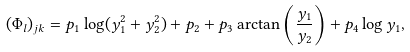<formula> <loc_0><loc_0><loc_500><loc_500>( \Phi _ { l } ) _ { j k } = p _ { 1 } \log ( y _ { 1 } ^ { 2 } + y _ { 2 } ^ { 2 } ) + p _ { 2 } + p _ { 3 } \arctan \left ( \frac { y _ { 1 } } { y _ { 2 } } \right ) + p _ { 4 } \log y _ { 1 } ,</formula> 